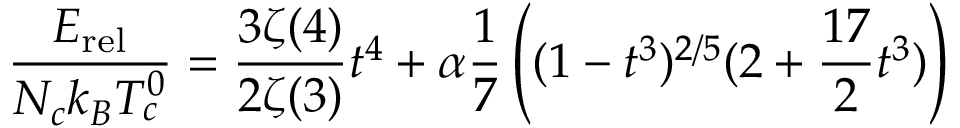Convert formula to latex. <formula><loc_0><loc_0><loc_500><loc_500>\frac { E _ { r e l } } { N _ { c } k _ { B } T _ { c } ^ { 0 } } = \frac { 3 \zeta ( 4 ) } { 2 \zeta ( 3 ) } t ^ { 4 } + \alpha \frac { 1 } { 7 } \left ( ( 1 - t ^ { 3 } ) ^ { 2 / 5 } ( 2 + \frac { 1 7 } { 2 } t ^ { 3 } ) \right )</formula> 